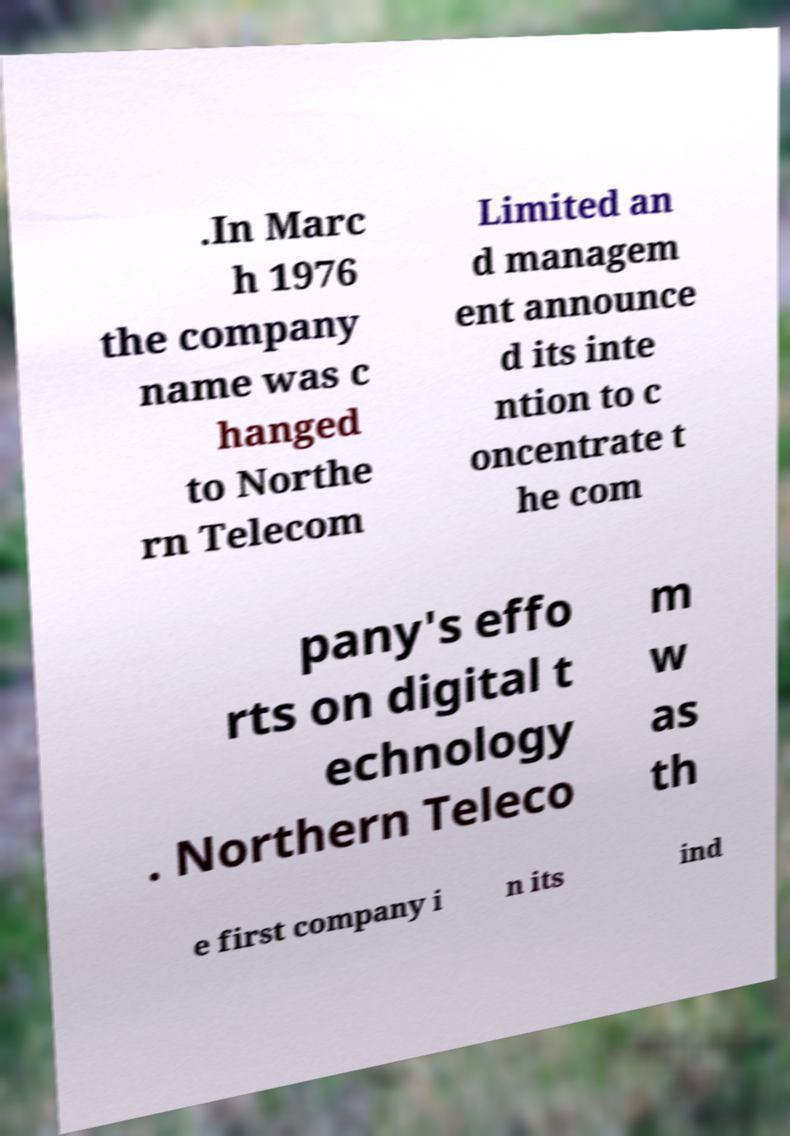Can you read and provide the text displayed in the image?This photo seems to have some interesting text. Can you extract and type it out for me? .In Marc h 1976 the company name was c hanged to Northe rn Telecom Limited an d managem ent announce d its inte ntion to c oncentrate t he com pany's effo rts on digital t echnology . Northern Teleco m w as th e first company i n its ind 